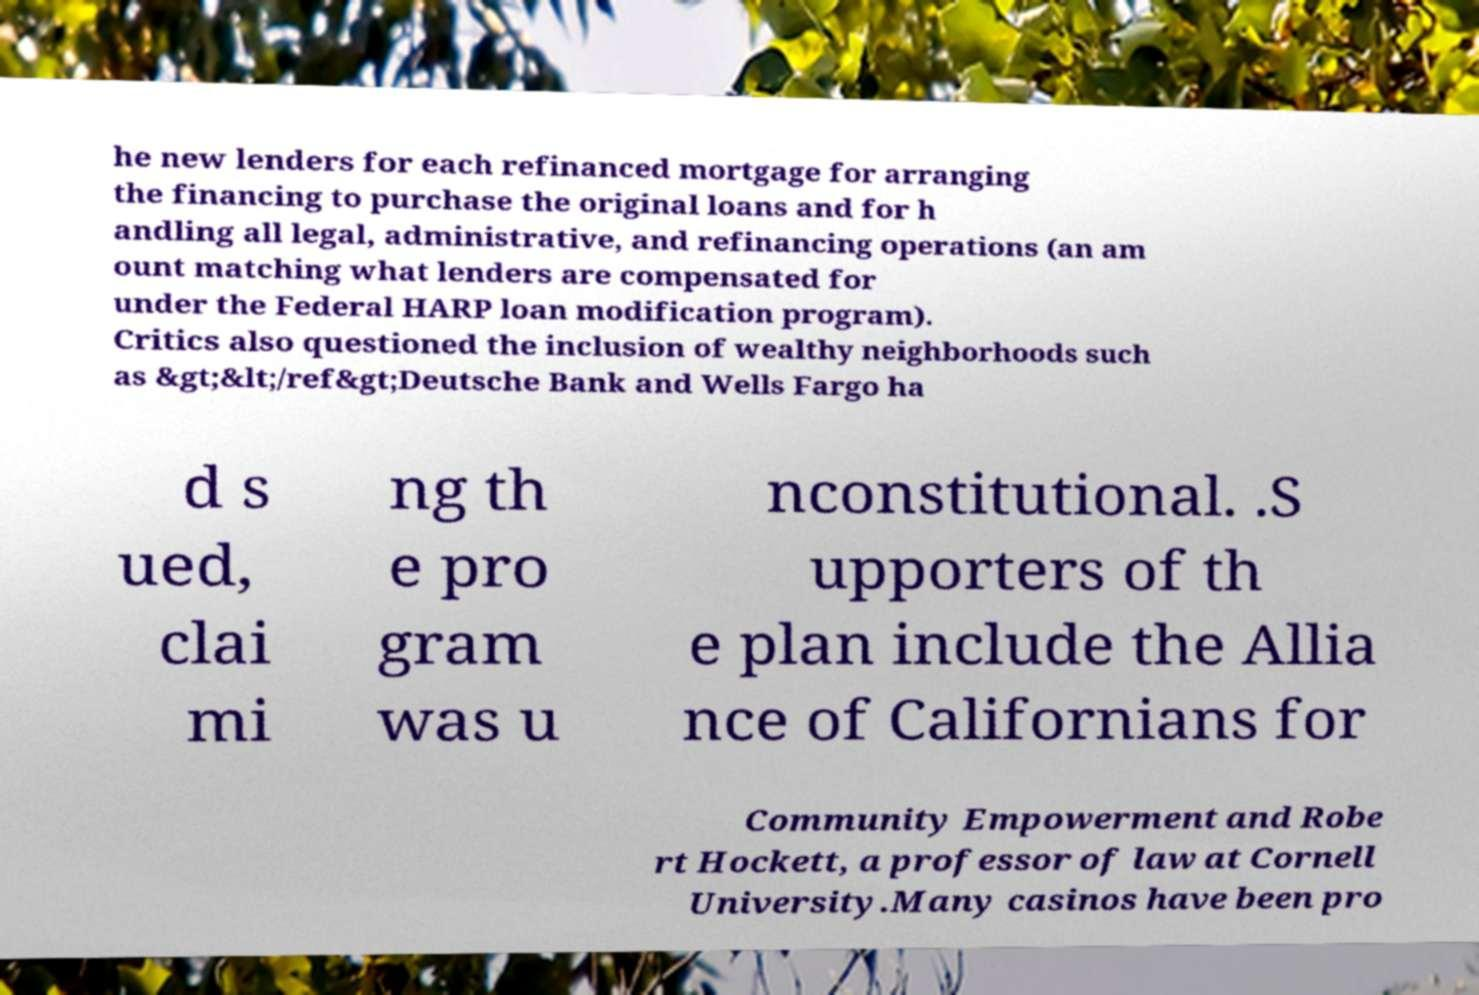There's text embedded in this image that I need extracted. Can you transcribe it verbatim? he new lenders for each refinanced mortgage for arranging the financing to purchase the original loans and for h andling all legal, administrative, and refinancing operations (an am ount matching what lenders are compensated for under the Federal HARP loan modification program). Critics also questioned the inclusion of wealthy neighborhoods such as &gt;&lt;/ref&gt;Deutsche Bank and Wells Fargo ha d s ued, clai mi ng th e pro gram was u nconstitutional. .S upporters of th e plan include the Allia nce of Californians for Community Empowerment and Robe rt Hockett, a professor of law at Cornell University.Many casinos have been pro 